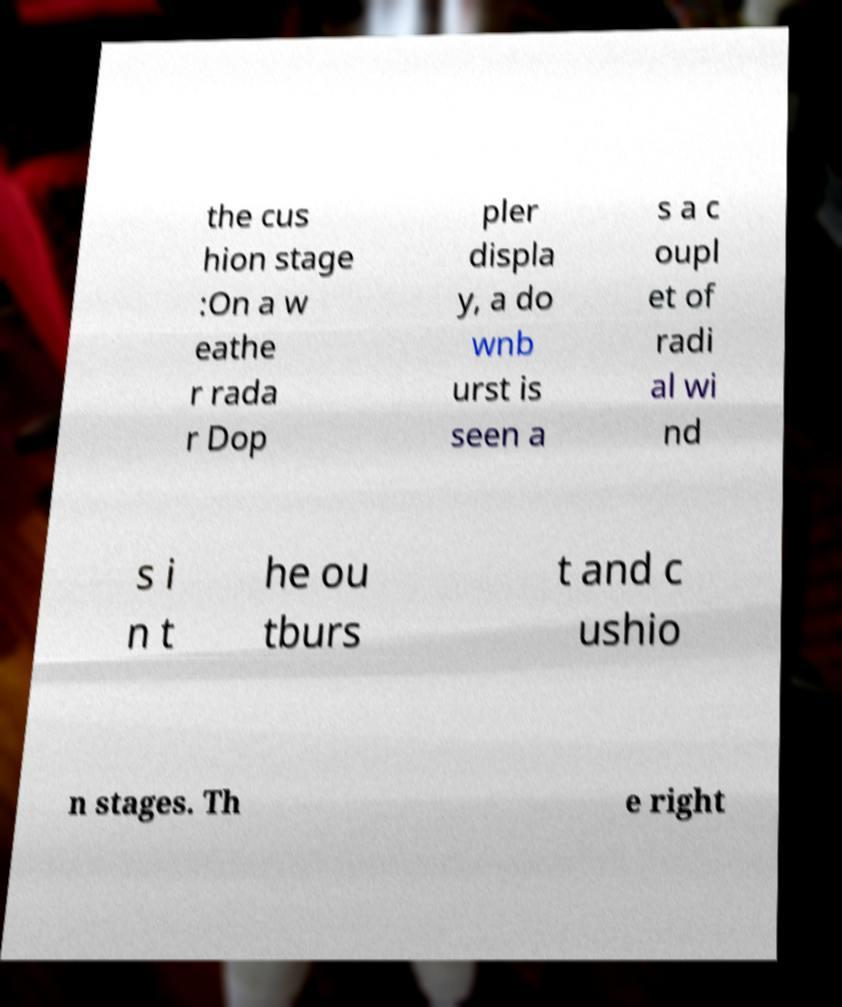Could you extract and type out the text from this image? the cus hion stage :On a w eathe r rada r Dop pler displa y, a do wnb urst is seen a s a c oupl et of radi al wi nd s i n t he ou tburs t and c ushio n stages. Th e right 